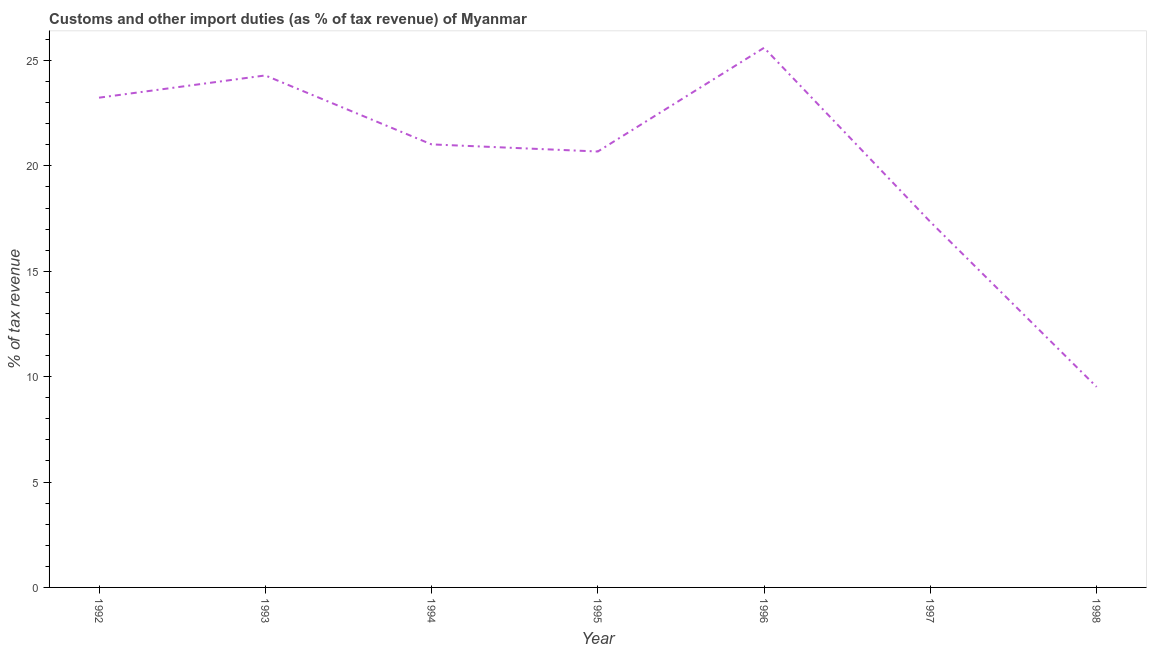What is the customs and other import duties in 1992?
Give a very brief answer. 23.23. Across all years, what is the maximum customs and other import duties?
Offer a very short reply. 25.6. Across all years, what is the minimum customs and other import duties?
Offer a terse response. 9.51. What is the sum of the customs and other import duties?
Provide a succinct answer. 141.68. What is the difference between the customs and other import duties in 1994 and 1998?
Ensure brevity in your answer.  11.5. What is the average customs and other import duties per year?
Your answer should be compact. 20.24. What is the median customs and other import duties?
Your response must be concise. 21.02. What is the ratio of the customs and other import duties in 1992 to that in 1998?
Keep it short and to the point. 2.44. What is the difference between the highest and the second highest customs and other import duties?
Provide a succinct answer. 1.31. Is the sum of the customs and other import duties in 1995 and 1996 greater than the maximum customs and other import duties across all years?
Your response must be concise. Yes. What is the difference between the highest and the lowest customs and other import duties?
Keep it short and to the point. 16.09. How many lines are there?
Your response must be concise. 1. Does the graph contain grids?
Give a very brief answer. No. What is the title of the graph?
Keep it short and to the point. Customs and other import duties (as % of tax revenue) of Myanmar. What is the label or title of the X-axis?
Keep it short and to the point. Year. What is the label or title of the Y-axis?
Give a very brief answer. % of tax revenue. What is the % of tax revenue of 1992?
Offer a very short reply. 23.23. What is the % of tax revenue in 1993?
Your answer should be very brief. 24.29. What is the % of tax revenue in 1994?
Provide a succinct answer. 21.02. What is the % of tax revenue of 1995?
Provide a short and direct response. 20.68. What is the % of tax revenue of 1996?
Provide a short and direct response. 25.6. What is the % of tax revenue in 1997?
Provide a short and direct response. 17.34. What is the % of tax revenue of 1998?
Provide a succinct answer. 9.51. What is the difference between the % of tax revenue in 1992 and 1993?
Offer a very short reply. -1.05. What is the difference between the % of tax revenue in 1992 and 1994?
Provide a short and direct response. 2.22. What is the difference between the % of tax revenue in 1992 and 1995?
Your answer should be very brief. 2.55. What is the difference between the % of tax revenue in 1992 and 1996?
Make the answer very short. -2.37. What is the difference between the % of tax revenue in 1992 and 1997?
Offer a terse response. 5.89. What is the difference between the % of tax revenue in 1992 and 1998?
Provide a succinct answer. 13.72. What is the difference between the % of tax revenue in 1993 and 1994?
Your answer should be very brief. 3.27. What is the difference between the % of tax revenue in 1993 and 1995?
Your answer should be compact. 3.61. What is the difference between the % of tax revenue in 1993 and 1996?
Give a very brief answer. -1.31. What is the difference between the % of tax revenue in 1993 and 1997?
Ensure brevity in your answer.  6.95. What is the difference between the % of tax revenue in 1993 and 1998?
Make the answer very short. 14.78. What is the difference between the % of tax revenue in 1994 and 1995?
Ensure brevity in your answer.  0.34. What is the difference between the % of tax revenue in 1994 and 1996?
Provide a short and direct response. -4.58. What is the difference between the % of tax revenue in 1994 and 1997?
Your response must be concise. 3.68. What is the difference between the % of tax revenue in 1994 and 1998?
Give a very brief answer. 11.5. What is the difference between the % of tax revenue in 1995 and 1996?
Give a very brief answer. -4.92. What is the difference between the % of tax revenue in 1995 and 1997?
Keep it short and to the point. 3.34. What is the difference between the % of tax revenue in 1995 and 1998?
Offer a very short reply. 11.17. What is the difference between the % of tax revenue in 1996 and 1997?
Your answer should be compact. 8.26. What is the difference between the % of tax revenue in 1996 and 1998?
Provide a succinct answer. 16.09. What is the difference between the % of tax revenue in 1997 and 1998?
Ensure brevity in your answer.  7.83. What is the ratio of the % of tax revenue in 1992 to that in 1994?
Provide a succinct answer. 1.1. What is the ratio of the % of tax revenue in 1992 to that in 1995?
Give a very brief answer. 1.12. What is the ratio of the % of tax revenue in 1992 to that in 1996?
Your answer should be very brief. 0.91. What is the ratio of the % of tax revenue in 1992 to that in 1997?
Make the answer very short. 1.34. What is the ratio of the % of tax revenue in 1992 to that in 1998?
Your response must be concise. 2.44. What is the ratio of the % of tax revenue in 1993 to that in 1994?
Your answer should be compact. 1.16. What is the ratio of the % of tax revenue in 1993 to that in 1995?
Provide a short and direct response. 1.17. What is the ratio of the % of tax revenue in 1993 to that in 1996?
Your response must be concise. 0.95. What is the ratio of the % of tax revenue in 1993 to that in 1997?
Make the answer very short. 1.4. What is the ratio of the % of tax revenue in 1993 to that in 1998?
Offer a very short reply. 2.55. What is the ratio of the % of tax revenue in 1994 to that in 1995?
Your response must be concise. 1.02. What is the ratio of the % of tax revenue in 1994 to that in 1996?
Your answer should be compact. 0.82. What is the ratio of the % of tax revenue in 1994 to that in 1997?
Your response must be concise. 1.21. What is the ratio of the % of tax revenue in 1994 to that in 1998?
Make the answer very short. 2.21. What is the ratio of the % of tax revenue in 1995 to that in 1996?
Offer a very short reply. 0.81. What is the ratio of the % of tax revenue in 1995 to that in 1997?
Offer a terse response. 1.19. What is the ratio of the % of tax revenue in 1995 to that in 1998?
Make the answer very short. 2.17. What is the ratio of the % of tax revenue in 1996 to that in 1997?
Provide a succinct answer. 1.48. What is the ratio of the % of tax revenue in 1996 to that in 1998?
Give a very brief answer. 2.69. What is the ratio of the % of tax revenue in 1997 to that in 1998?
Provide a succinct answer. 1.82. 